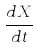<formula> <loc_0><loc_0><loc_500><loc_500>\frac { d X } { d t }</formula> 